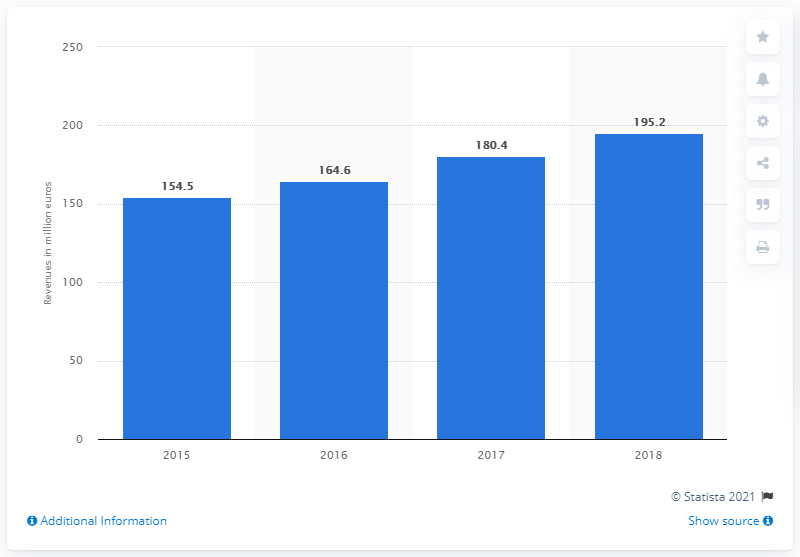Give some essential details in this illustration. In 2018, the revenue of Botter S.p.A. was 195.2 million euros. The revenue of Botter S.p.A in 2015 was 154.5 million. 